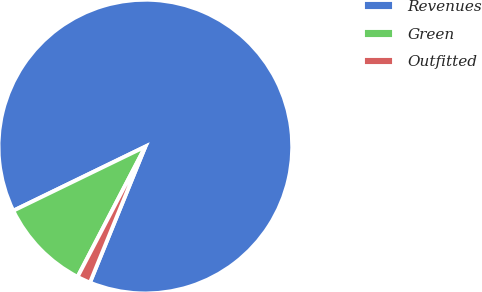<chart> <loc_0><loc_0><loc_500><loc_500><pie_chart><fcel>Revenues<fcel>Green<fcel>Outfitted<nl><fcel>88.35%<fcel>10.17%<fcel>1.48%<nl></chart> 